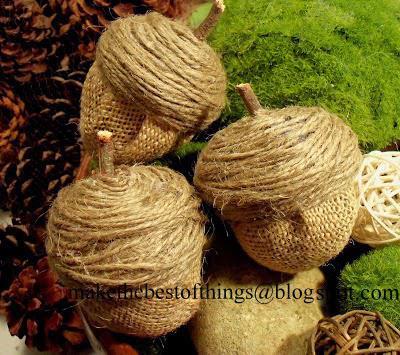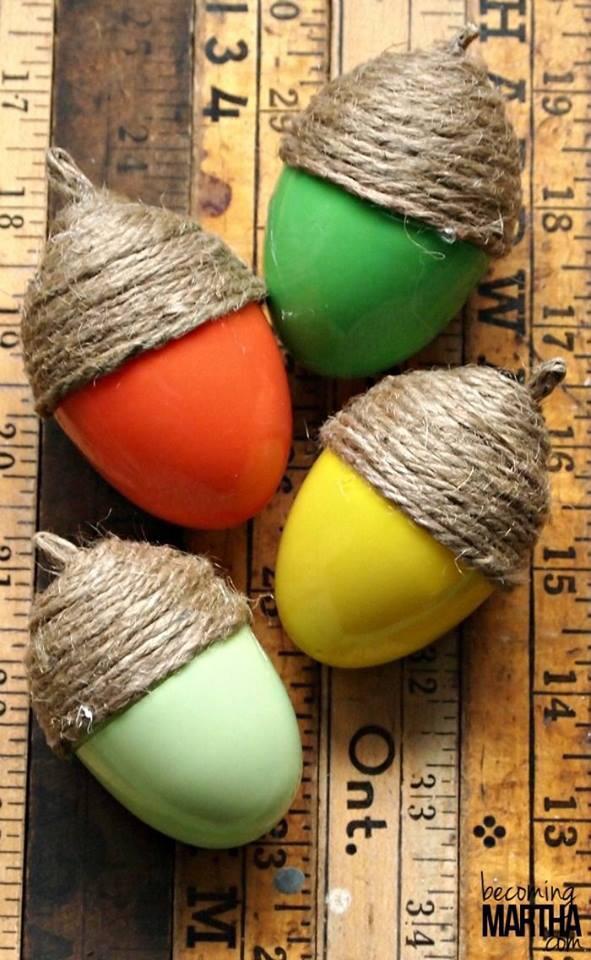The first image is the image on the left, the second image is the image on the right. Analyze the images presented: Is the assertion "Nothing is edible." valid? Answer yes or no. Yes. The first image is the image on the left, the second image is the image on the right. Analyze the images presented: Is the assertion "Each image shows acorn caps made of wrapped twine, and at least one image includes acorns made of plastic eggs in orange, yellow and green colors." valid? Answer yes or no. Yes. 